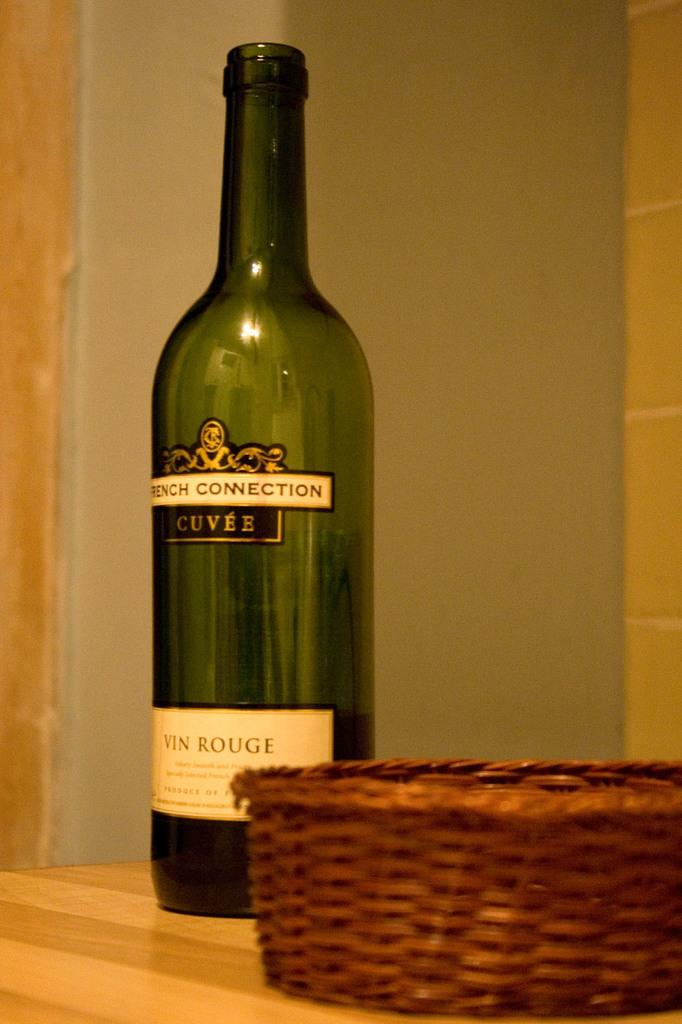<image>
Create a compact narrative representing the image presented. A bottle of wine called FRENCH CONNECTION CUVEE sits on a table. 